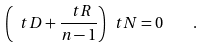<formula> <loc_0><loc_0><loc_500><loc_500>\left ( \ t D + \frac { \ t R } { n - 1 } \right ) \ t N = 0 \quad .</formula> 